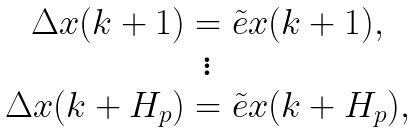<formula> <loc_0><loc_0><loc_500><loc_500>\begin{array} { c } \Delta x ( k + 1 ) = \tilde { e } x ( k + 1 ) , \\ \vdots \\ \Delta x ( k + H _ { p } ) = \tilde { e } x ( k + H _ { p } ) , \end{array}</formula> 